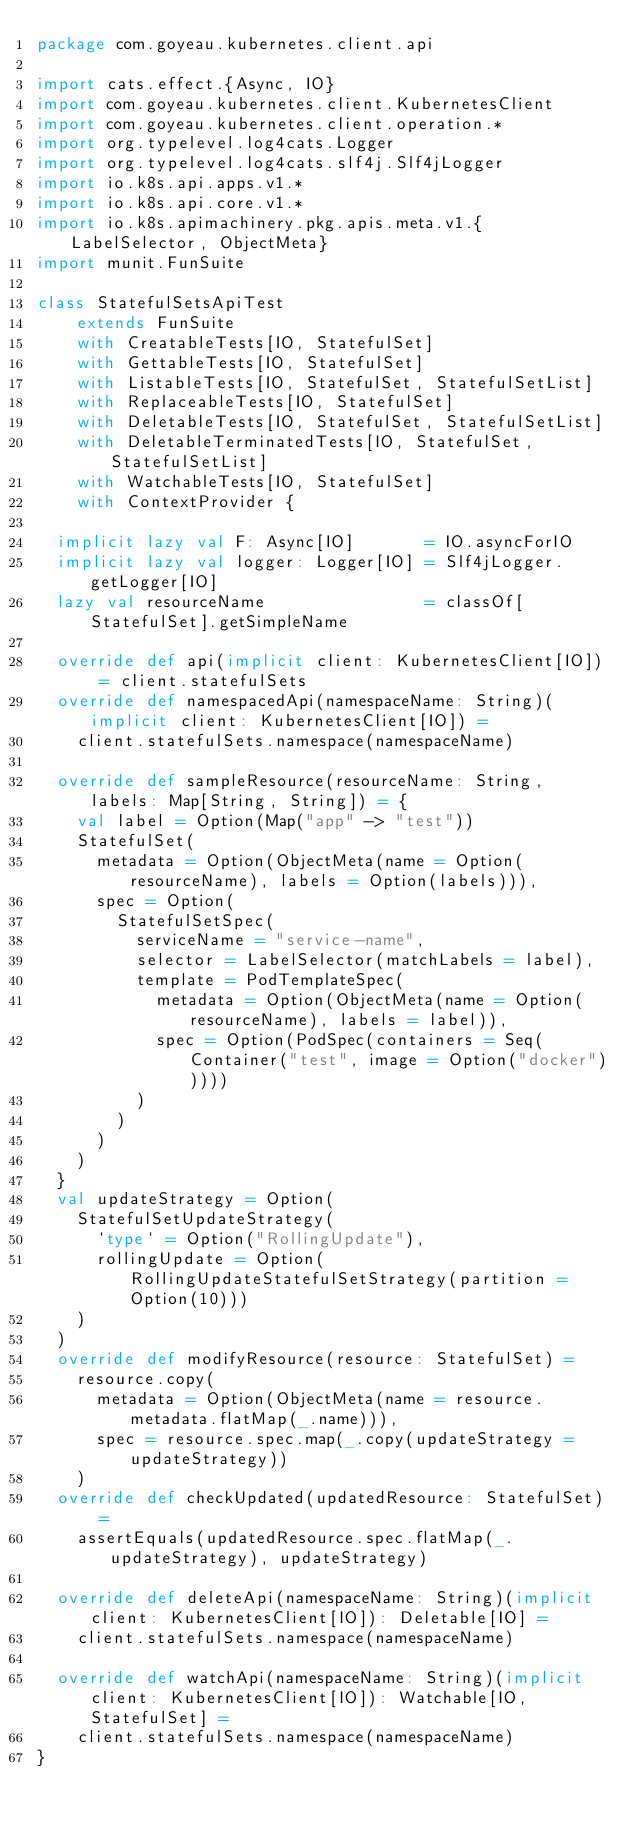<code> <loc_0><loc_0><loc_500><loc_500><_Scala_>package com.goyeau.kubernetes.client.api

import cats.effect.{Async, IO}
import com.goyeau.kubernetes.client.KubernetesClient
import com.goyeau.kubernetes.client.operation.*
import org.typelevel.log4cats.Logger
import org.typelevel.log4cats.slf4j.Slf4jLogger
import io.k8s.api.apps.v1.*
import io.k8s.api.core.v1.*
import io.k8s.apimachinery.pkg.apis.meta.v1.{LabelSelector, ObjectMeta}
import munit.FunSuite

class StatefulSetsApiTest
    extends FunSuite
    with CreatableTests[IO, StatefulSet]
    with GettableTests[IO, StatefulSet]
    with ListableTests[IO, StatefulSet, StatefulSetList]
    with ReplaceableTests[IO, StatefulSet]
    with DeletableTests[IO, StatefulSet, StatefulSetList]
    with DeletableTerminatedTests[IO, StatefulSet, StatefulSetList]
    with WatchableTests[IO, StatefulSet]
    with ContextProvider {

  implicit lazy val F: Async[IO]       = IO.asyncForIO
  implicit lazy val logger: Logger[IO] = Slf4jLogger.getLogger[IO]
  lazy val resourceName                = classOf[StatefulSet].getSimpleName

  override def api(implicit client: KubernetesClient[IO]) = client.statefulSets
  override def namespacedApi(namespaceName: String)(implicit client: KubernetesClient[IO]) =
    client.statefulSets.namespace(namespaceName)

  override def sampleResource(resourceName: String, labels: Map[String, String]) = {
    val label = Option(Map("app" -> "test"))
    StatefulSet(
      metadata = Option(ObjectMeta(name = Option(resourceName), labels = Option(labels))),
      spec = Option(
        StatefulSetSpec(
          serviceName = "service-name",
          selector = LabelSelector(matchLabels = label),
          template = PodTemplateSpec(
            metadata = Option(ObjectMeta(name = Option(resourceName), labels = label)),
            spec = Option(PodSpec(containers = Seq(Container("test", image = Option("docker")))))
          )
        )
      )
    )
  }
  val updateStrategy = Option(
    StatefulSetUpdateStrategy(
      `type` = Option("RollingUpdate"),
      rollingUpdate = Option(RollingUpdateStatefulSetStrategy(partition = Option(10)))
    )
  )
  override def modifyResource(resource: StatefulSet) =
    resource.copy(
      metadata = Option(ObjectMeta(name = resource.metadata.flatMap(_.name))),
      spec = resource.spec.map(_.copy(updateStrategy = updateStrategy))
    )
  override def checkUpdated(updatedResource: StatefulSet) =
    assertEquals(updatedResource.spec.flatMap(_.updateStrategy), updateStrategy)

  override def deleteApi(namespaceName: String)(implicit client: KubernetesClient[IO]): Deletable[IO] =
    client.statefulSets.namespace(namespaceName)

  override def watchApi(namespaceName: String)(implicit client: KubernetesClient[IO]): Watchable[IO, StatefulSet] =
    client.statefulSets.namespace(namespaceName)
}
</code> 